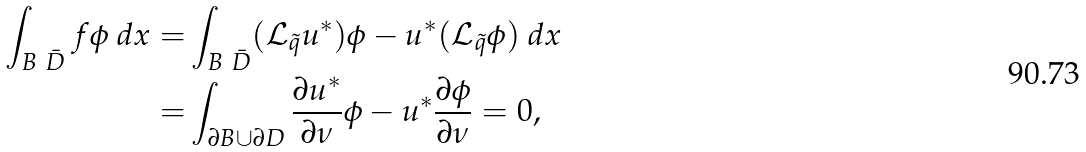Convert formula to latex. <formula><loc_0><loc_0><loc_500><loc_500>\int _ { B \ \bar { D } } f \phi \ d x = & \int _ { B \ \bar { D } } ( \mathcal { L } _ { \tilde { q } } u ^ { * } ) \phi - u ^ { * } ( \mathcal { L } _ { \tilde { q } } \phi ) \ d x \\ = & \int _ { \partial B \cup \partial D } \frac { \partial u ^ { * } } { \partial \nu } \phi - u ^ { * } \frac { \partial \phi } { \partial \nu } = 0 ,</formula> 